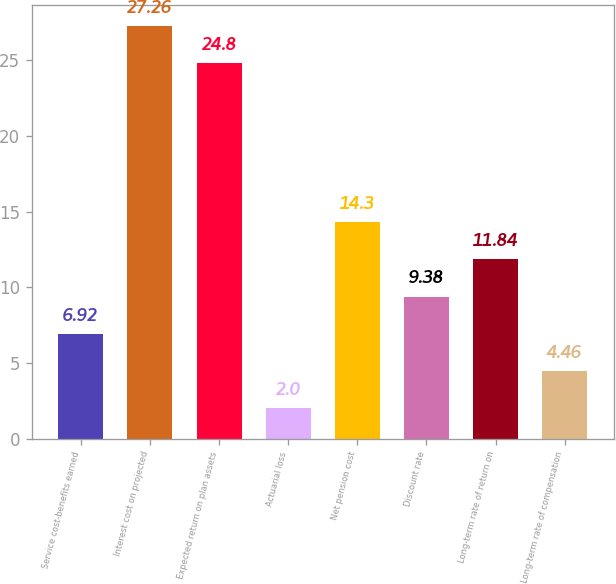Convert chart. <chart><loc_0><loc_0><loc_500><loc_500><bar_chart><fcel>Service cost-benefits earned<fcel>Interest cost on projected<fcel>Expected return on plan assets<fcel>Actuarial loss<fcel>Net pension cost<fcel>Discount rate<fcel>Long-term rate of return on<fcel>Long-term rate of compensation<nl><fcel>6.92<fcel>27.26<fcel>24.8<fcel>2<fcel>14.3<fcel>9.38<fcel>11.84<fcel>4.46<nl></chart> 